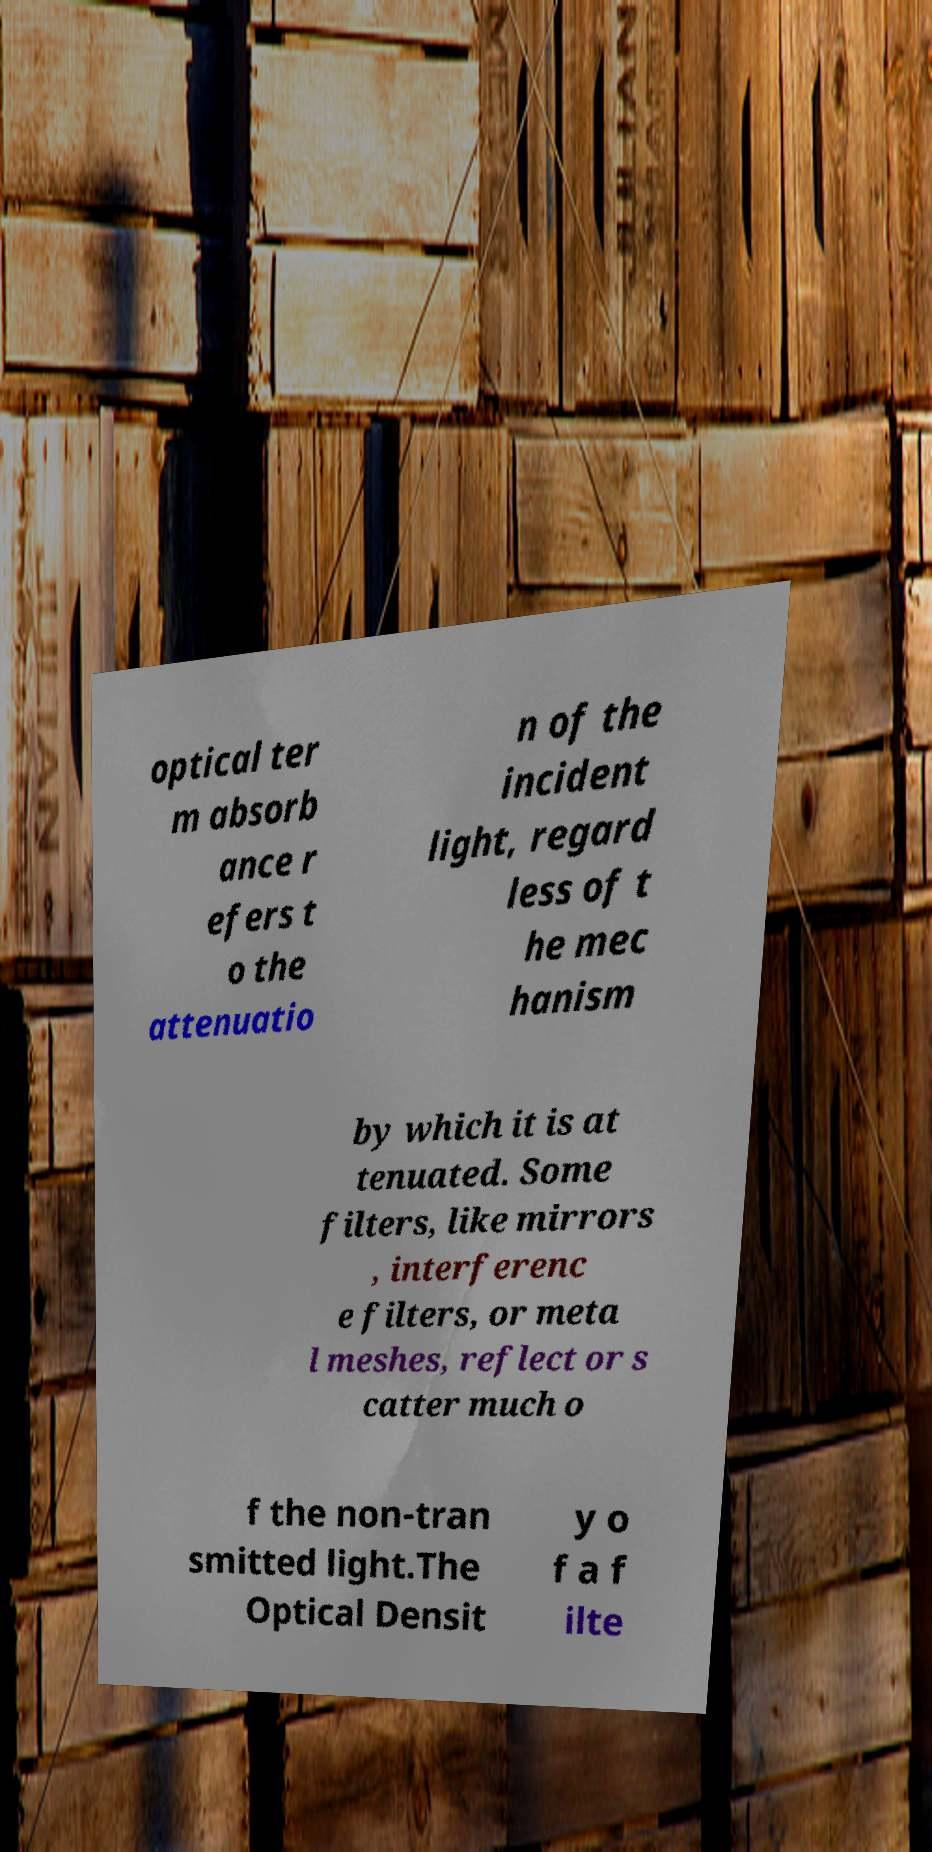What messages or text are displayed in this image? I need them in a readable, typed format. optical ter m absorb ance r efers t o the attenuatio n of the incident light, regard less of t he mec hanism by which it is at tenuated. Some filters, like mirrors , interferenc e filters, or meta l meshes, reflect or s catter much o f the non-tran smitted light.The Optical Densit y o f a f ilte 